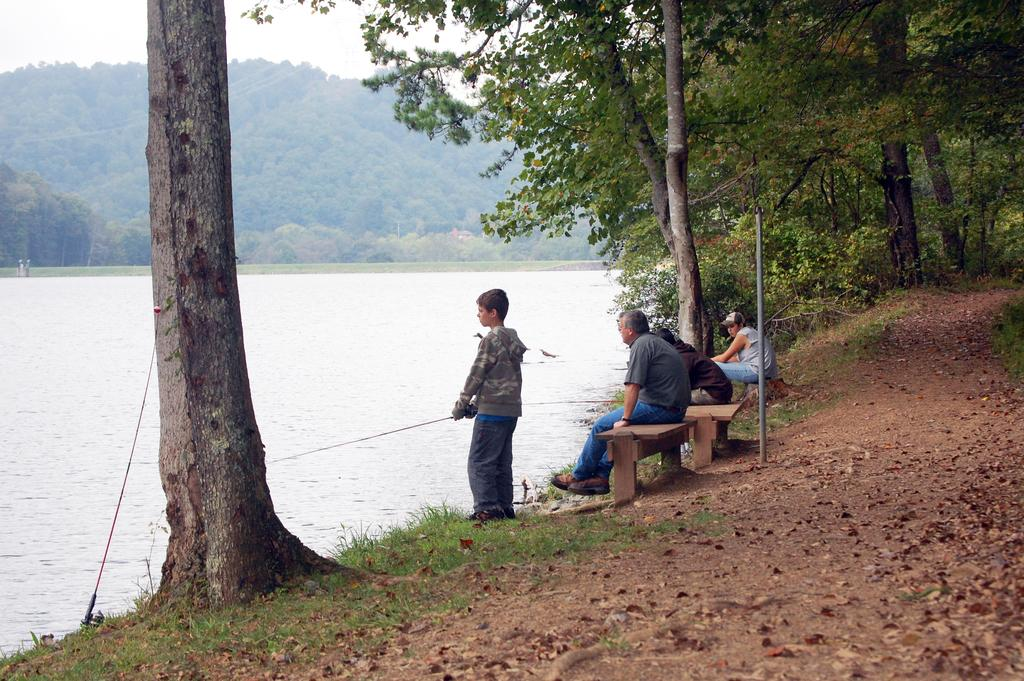What type of natural elements can be seen in the image? There are trees and water visible in the image. What is visible in the background of the image? The sky is visible in the image. What are the people in the image doing? There are people sitting on a bench in the image. What type of office furniture can be seen in the image? There is no office furniture present in the image. Can you describe the hole in the image? There is no hole present in the image. 